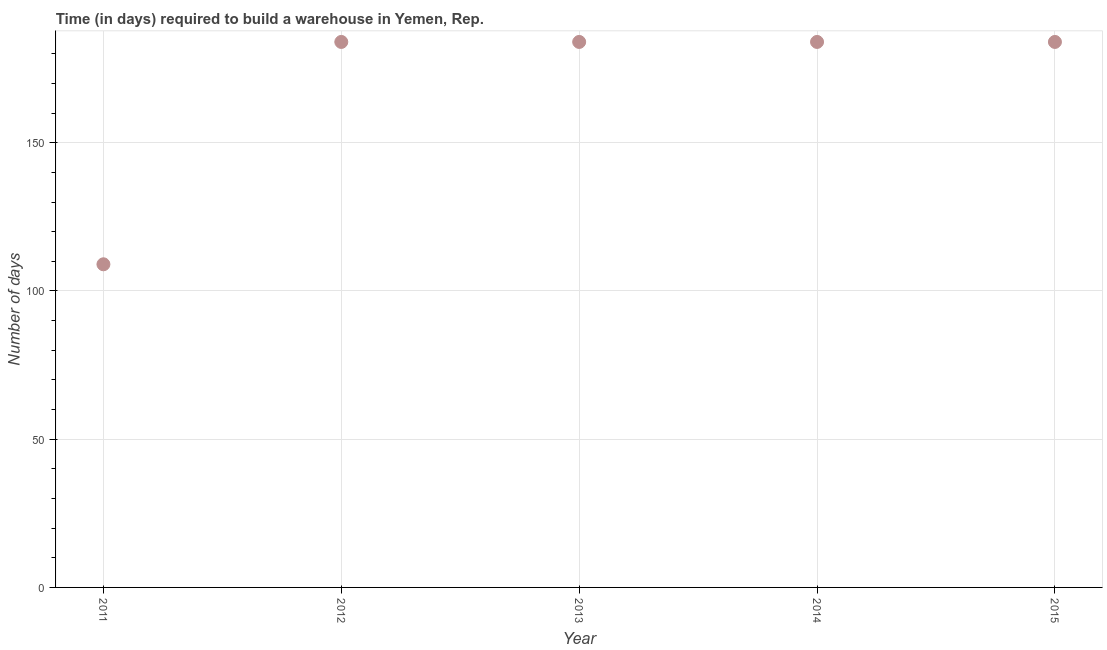What is the time required to build a warehouse in 2011?
Keep it short and to the point. 109. Across all years, what is the maximum time required to build a warehouse?
Keep it short and to the point. 184. Across all years, what is the minimum time required to build a warehouse?
Offer a very short reply. 109. In which year was the time required to build a warehouse minimum?
Make the answer very short. 2011. What is the sum of the time required to build a warehouse?
Your answer should be very brief. 845. What is the difference between the time required to build a warehouse in 2011 and 2014?
Ensure brevity in your answer.  -75. What is the average time required to build a warehouse per year?
Offer a terse response. 169. What is the median time required to build a warehouse?
Keep it short and to the point. 184. In how many years, is the time required to build a warehouse greater than 160 days?
Give a very brief answer. 4. Do a majority of the years between 2012 and 2011 (inclusive) have time required to build a warehouse greater than 120 days?
Offer a very short reply. No. What is the ratio of the time required to build a warehouse in 2011 to that in 2012?
Your response must be concise. 0.59. Is the time required to build a warehouse in 2012 less than that in 2015?
Keep it short and to the point. No. What is the difference between the highest and the lowest time required to build a warehouse?
Offer a very short reply. 75. In how many years, is the time required to build a warehouse greater than the average time required to build a warehouse taken over all years?
Your response must be concise. 4. How many dotlines are there?
Your answer should be very brief. 1. Does the graph contain any zero values?
Your answer should be very brief. No. Does the graph contain grids?
Your answer should be compact. Yes. What is the title of the graph?
Ensure brevity in your answer.  Time (in days) required to build a warehouse in Yemen, Rep. What is the label or title of the X-axis?
Provide a succinct answer. Year. What is the label or title of the Y-axis?
Your answer should be very brief. Number of days. What is the Number of days in 2011?
Your answer should be very brief. 109. What is the Number of days in 2012?
Keep it short and to the point. 184. What is the Number of days in 2013?
Offer a terse response. 184. What is the Number of days in 2014?
Provide a short and direct response. 184. What is the Number of days in 2015?
Your response must be concise. 184. What is the difference between the Number of days in 2011 and 2012?
Make the answer very short. -75. What is the difference between the Number of days in 2011 and 2013?
Ensure brevity in your answer.  -75. What is the difference between the Number of days in 2011 and 2014?
Offer a very short reply. -75. What is the difference between the Number of days in 2011 and 2015?
Keep it short and to the point. -75. What is the difference between the Number of days in 2012 and 2013?
Offer a terse response. 0. What is the difference between the Number of days in 2012 and 2014?
Keep it short and to the point. 0. What is the difference between the Number of days in 2013 and 2015?
Your answer should be very brief. 0. What is the difference between the Number of days in 2014 and 2015?
Offer a terse response. 0. What is the ratio of the Number of days in 2011 to that in 2012?
Keep it short and to the point. 0.59. What is the ratio of the Number of days in 2011 to that in 2013?
Ensure brevity in your answer.  0.59. What is the ratio of the Number of days in 2011 to that in 2014?
Keep it short and to the point. 0.59. What is the ratio of the Number of days in 2011 to that in 2015?
Your answer should be very brief. 0.59. What is the ratio of the Number of days in 2012 to that in 2013?
Provide a succinct answer. 1. What is the ratio of the Number of days in 2012 to that in 2015?
Your response must be concise. 1. What is the ratio of the Number of days in 2013 to that in 2014?
Provide a short and direct response. 1. What is the ratio of the Number of days in 2013 to that in 2015?
Your answer should be compact. 1. What is the ratio of the Number of days in 2014 to that in 2015?
Your answer should be compact. 1. 